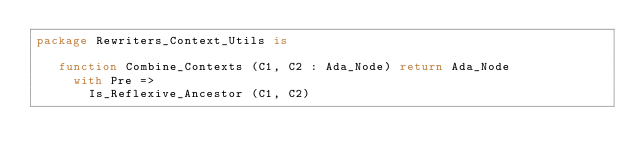<code> <loc_0><loc_0><loc_500><loc_500><_Ada_>package Rewriters_Context_Utils is

   function Combine_Contexts (C1, C2 : Ada_Node) return Ada_Node
     with Pre =>
       Is_Reflexive_Ancestor (C1, C2)</code> 